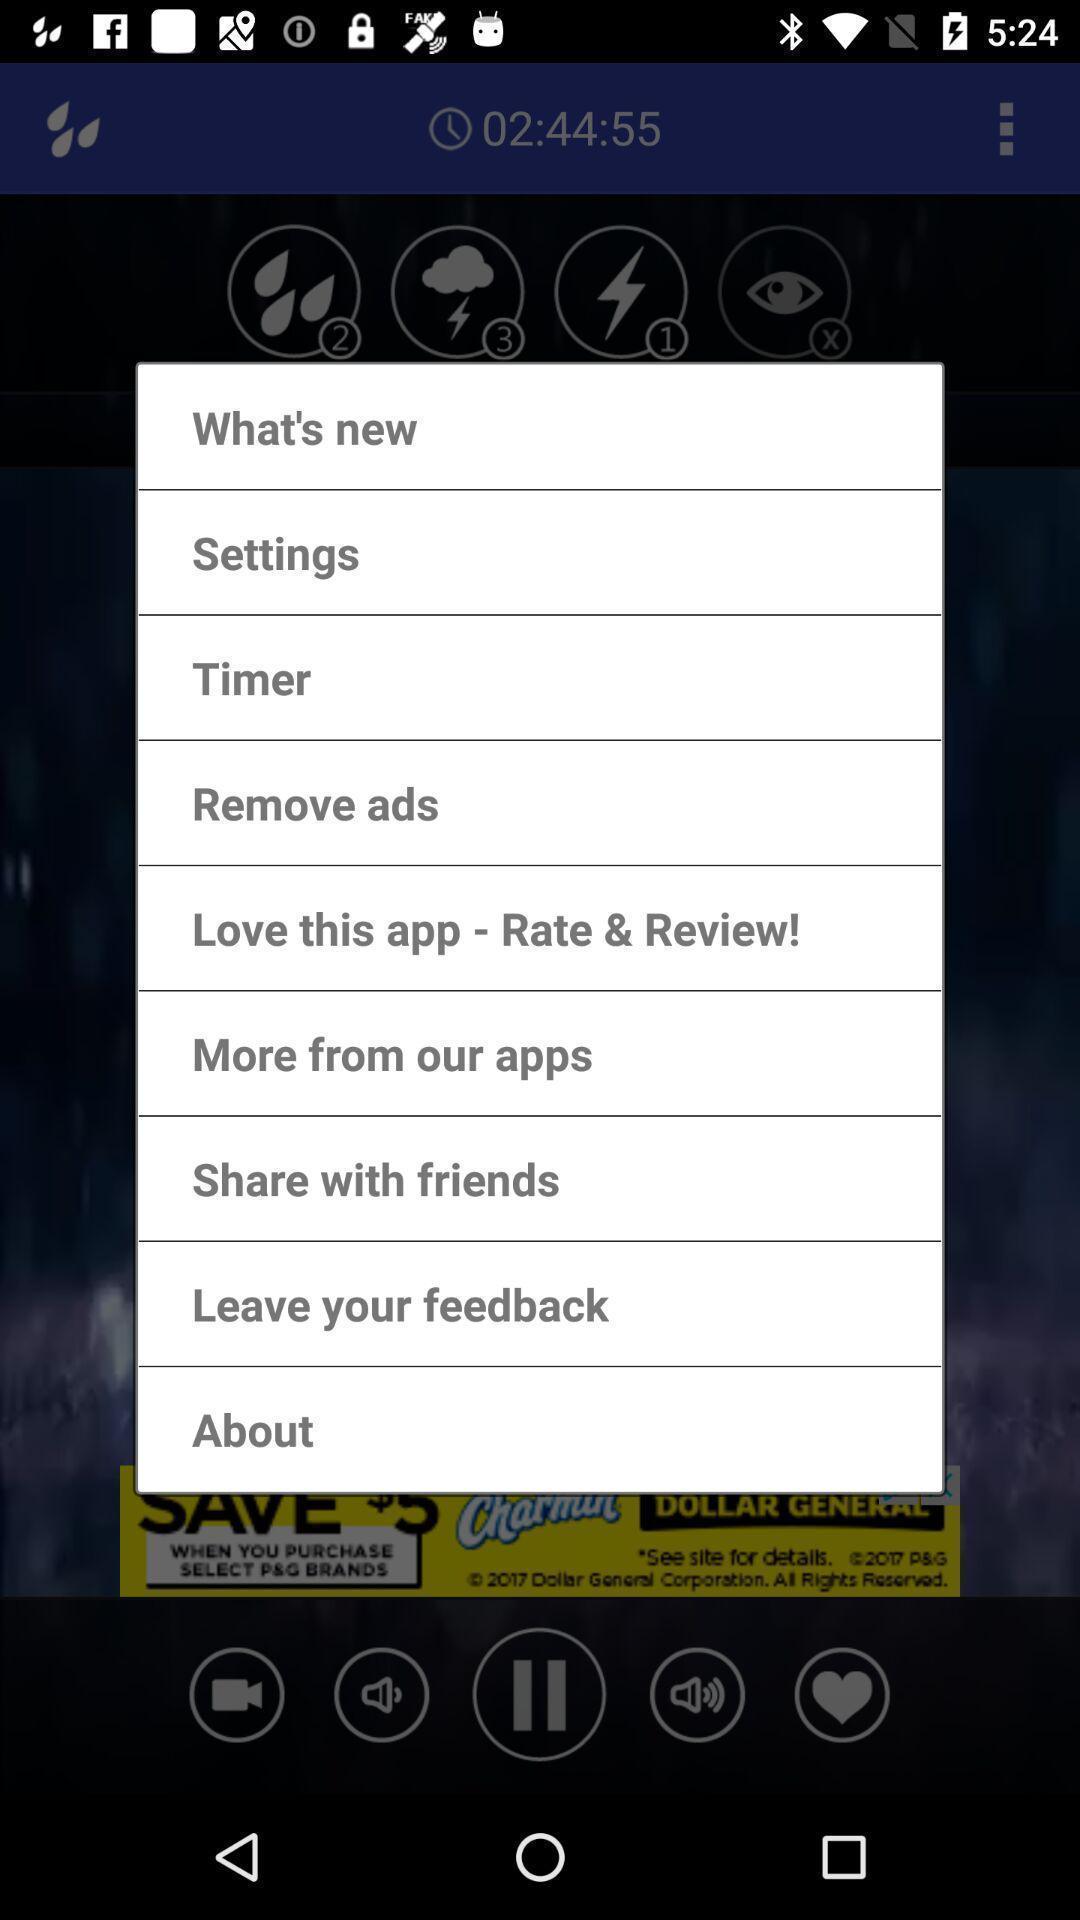Summarize the information in this screenshot. Pop-up displaying information about application. 